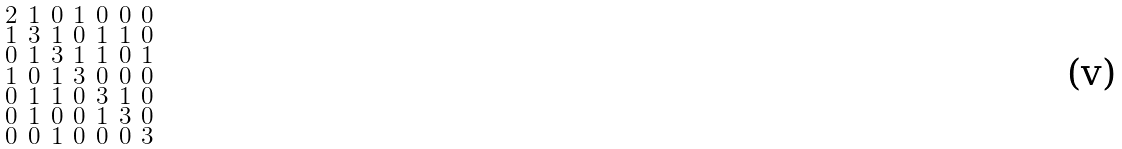<formula> <loc_0><loc_0><loc_500><loc_500>\begin{smallmatrix} 2 & 1 & 0 & 1 & 0 & 0 & 0 \\ 1 & 3 & 1 & 0 & 1 & 1 & 0 \\ 0 & 1 & 3 & 1 & 1 & 0 & 1 \\ 1 & 0 & 1 & 3 & 0 & 0 & 0 \\ 0 & 1 & 1 & 0 & 3 & 1 & 0 \\ 0 & 1 & 0 & 0 & 1 & 3 & 0 \\ 0 & 0 & 1 & 0 & 0 & 0 & 3 \end{smallmatrix}</formula> 